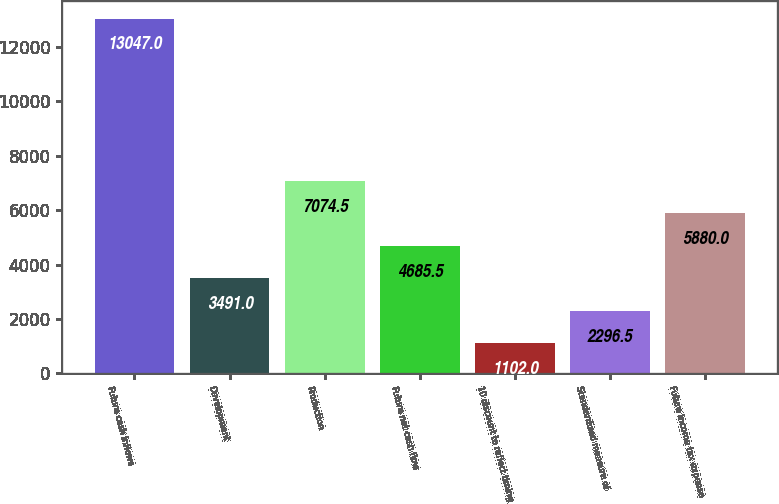<chart> <loc_0><loc_0><loc_500><loc_500><bar_chart><fcel>Future cash inflows<fcel>Development<fcel>Production<fcel>Future net cash flow<fcel>10 discount to reflect timing<fcel>Standardized measure of<fcel>Future income tax expense<nl><fcel>13047<fcel>3491<fcel>7074.5<fcel>4685.5<fcel>1102<fcel>2296.5<fcel>5880<nl></chart> 